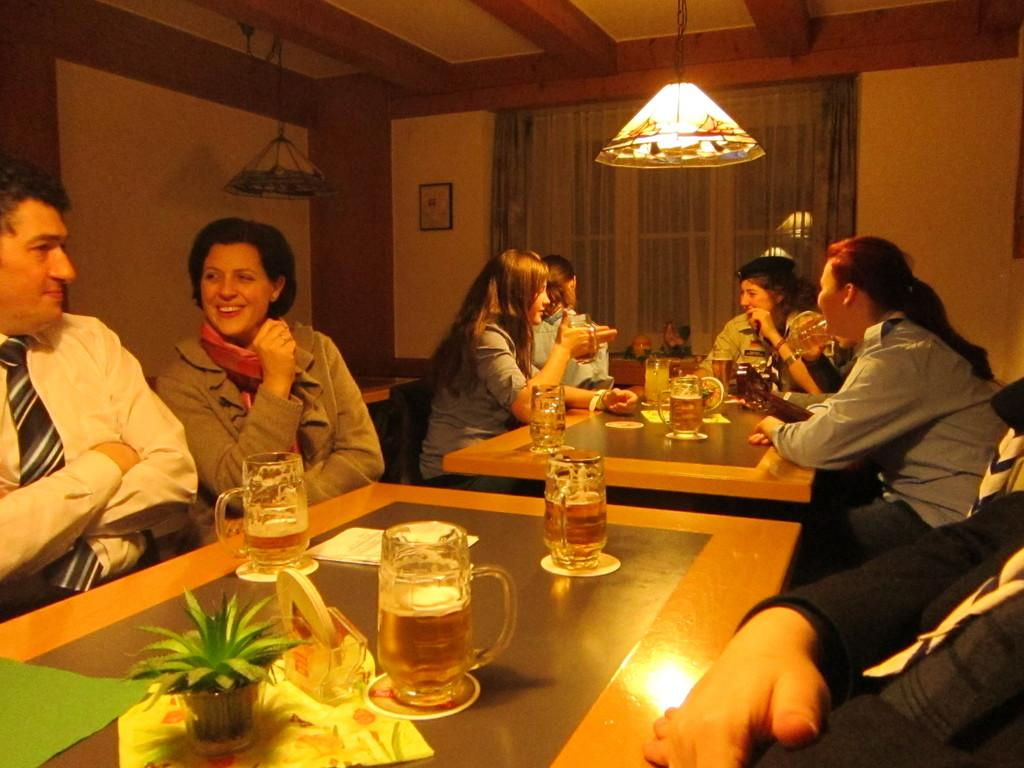How many people are in the image? There is a group of people in the image. What objects can be seen on the table? There are glasses and a pot on the table. What can be seen in the background of the image? There is a curtain in the background. What is hanging on the wall in the image? There is a frame on the wall. What type of lighting is present in the image? There is a light on the top. Can you see a branch being hammered by a worm in the image? No, there is no branch, hammer, or worm present in the image. 